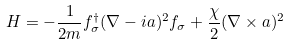<formula> <loc_0><loc_0><loc_500><loc_500>H = - \frac { 1 } { 2 m } f _ { \sigma } ^ { \dagger } ( \nabla - i { a } ) ^ { 2 } f _ { \sigma } + \frac { \chi } { 2 } ( \nabla \times { a } ) ^ { 2 }</formula> 